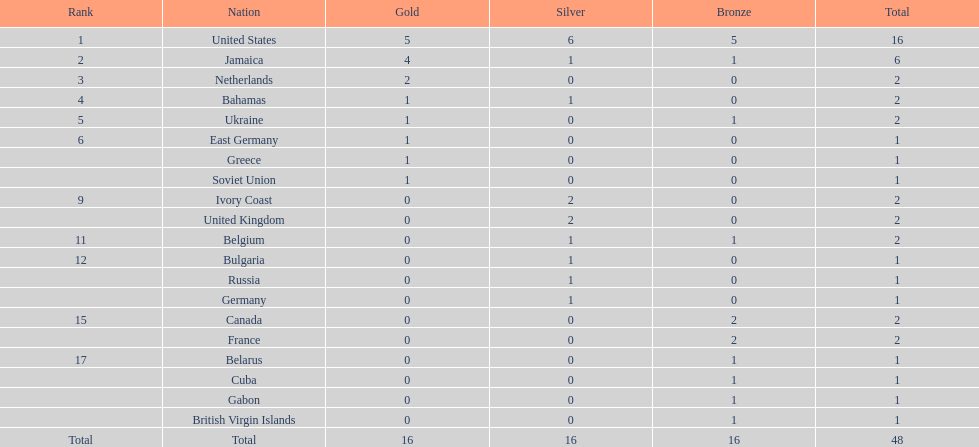In which country did the most gold medals get won? United States. 